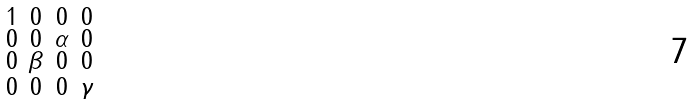<formula> <loc_0><loc_0><loc_500><loc_500>\begin{smallmatrix} 1 & 0 & 0 & 0 \\ 0 & 0 & \alpha & 0 \\ 0 & \beta & 0 & 0 \\ 0 & 0 & 0 & \gamma \\ \end{smallmatrix}</formula> 